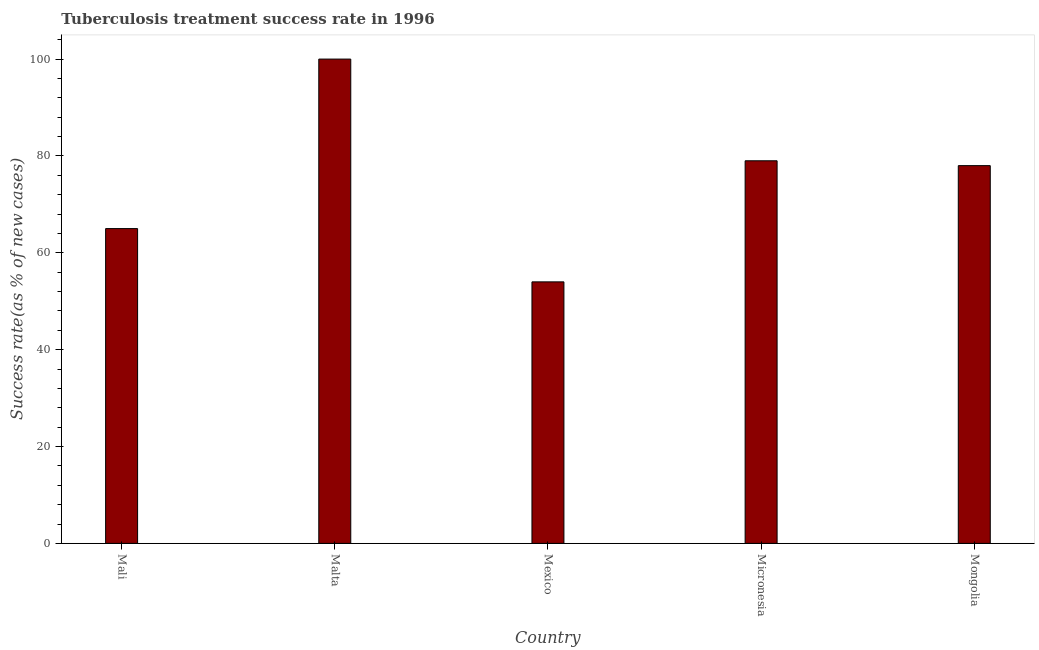Does the graph contain any zero values?
Provide a succinct answer. No. What is the title of the graph?
Offer a very short reply. Tuberculosis treatment success rate in 1996. What is the label or title of the Y-axis?
Make the answer very short. Success rate(as % of new cases). What is the tuberculosis treatment success rate in Mexico?
Offer a terse response. 54. In which country was the tuberculosis treatment success rate maximum?
Your answer should be very brief. Malta. In which country was the tuberculosis treatment success rate minimum?
Your answer should be very brief. Mexico. What is the sum of the tuberculosis treatment success rate?
Your response must be concise. 376. What is the difference between the tuberculosis treatment success rate in Mali and Malta?
Your response must be concise. -35. What is the ratio of the tuberculosis treatment success rate in Malta to that in Mongolia?
Make the answer very short. 1.28. Is the tuberculosis treatment success rate in Malta less than that in Mexico?
Ensure brevity in your answer.  No. Is the difference between the tuberculosis treatment success rate in Micronesia and Mongolia greater than the difference between any two countries?
Ensure brevity in your answer.  No. What is the difference between the highest and the second highest tuberculosis treatment success rate?
Ensure brevity in your answer.  21. Is the sum of the tuberculosis treatment success rate in Mali and Malta greater than the maximum tuberculosis treatment success rate across all countries?
Your answer should be compact. Yes. In how many countries, is the tuberculosis treatment success rate greater than the average tuberculosis treatment success rate taken over all countries?
Your answer should be very brief. 3. How many bars are there?
Give a very brief answer. 5. What is the difference between two consecutive major ticks on the Y-axis?
Keep it short and to the point. 20. Are the values on the major ticks of Y-axis written in scientific E-notation?
Your answer should be very brief. No. What is the Success rate(as % of new cases) of Mali?
Provide a succinct answer. 65. What is the Success rate(as % of new cases) of Mexico?
Give a very brief answer. 54. What is the Success rate(as % of new cases) of Micronesia?
Give a very brief answer. 79. What is the Success rate(as % of new cases) of Mongolia?
Provide a short and direct response. 78. What is the difference between the Success rate(as % of new cases) in Mali and Malta?
Provide a short and direct response. -35. What is the difference between the Success rate(as % of new cases) in Mali and Micronesia?
Offer a terse response. -14. What is the difference between the Success rate(as % of new cases) in Mali and Mongolia?
Keep it short and to the point. -13. What is the difference between the Success rate(as % of new cases) in Malta and Mexico?
Give a very brief answer. 46. What is the difference between the Success rate(as % of new cases) in Malta and Micronesia?
Your response must be concise. 21. What is the difference between the Success rate(as % of new cases) in Mexico and Micronesia?
Provide a succinct answer. -25. What is the difference between the Success rate(as % of new cases) in Mexico and Mongolia?
Give a very brief answer. -24. What is the ratio of the Success rate(as % of new cases) in Mali to that in Malta?
Keep it short and to the point. 0.65. What is the ratio of the Success rate(as % of new cases) in Mali to that in Mexico?
Offer a terse response. 1.2. What is the ratio of the Success rate(as % of new cases) in Mali to that in Micronesia?
Your answer should be compact. 0.82. What is the ratio of the Success rate(as % of new cases) in Mali to that in Mongolia?
Make the answer very short. 0.83. What is the ratio of the Success rate(as % of new cases) in Malta to that in Mexico?
Your answer should be compact. 1.85. What is the ratio of the Success rate(as % of new cases) in Malta to that in Micronesia?
Your answer should be very brief. 1.27. What is the ratio of the Success rate(as % of new cases) in Malta to that in Mongolia?
Your answer should be compact. 1.28. What is the ratio of the Success rate(as % of new cases) in Mexico to that in Micronesia?
Keep it short and to the point. 0.68. What is the ratio of the Success rate(as % of new cases) in Mexico to that in Mongolia?
Offer a very short reply. 0.69. 